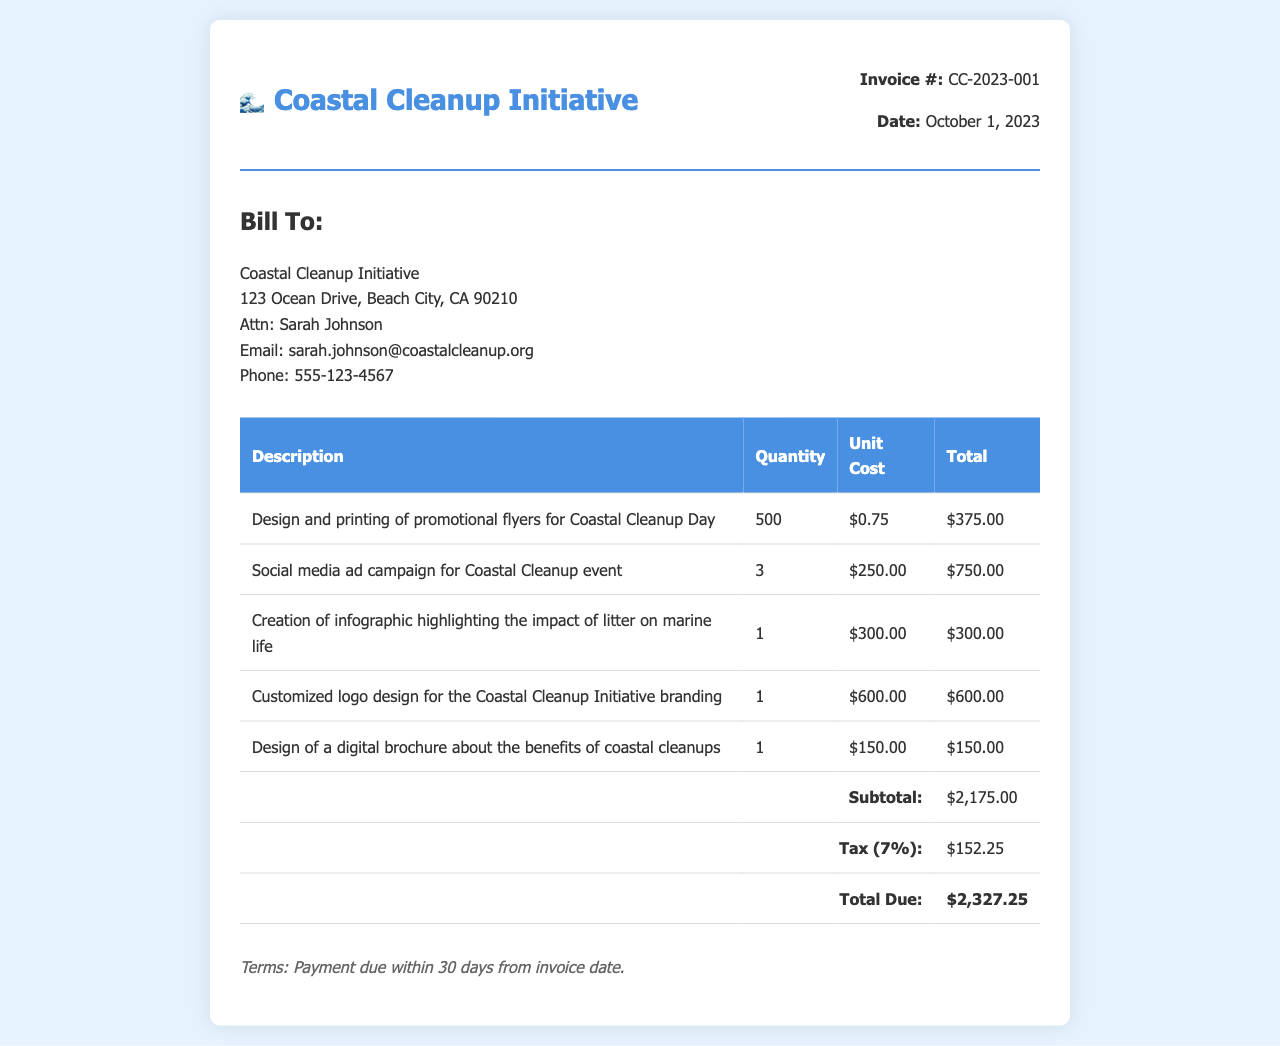What is the invoice number? The invoice number is indicated at the top of the document, labeled as "Invoice #".
Answer: CC-2023-001 What is the date of the invoice? The date is listed next to the invoice number, showing when the invoice was issued.
Answer: October 1, 2023 Who is the bill recipient? The recipient's name is shown under the "Bill To" section of the invoice.
Answer: Coastal Cleanup Initiative What is the total due amount? The total due is located at the bottom of the table, labeled as "Total Due".
Answer: $2,327.25 What is the unit cost for the social media ad campaign? The unit cost for the social media ad campaign is shown in the corresponding table row.
Answer: $250.00 How many promotional flyers were designed and printed? The quantity of flyers is detailed in the first table row under "Quantity".
Answer: 500 What is the subtotal amount? The subtotal is specified before the tax in the invoice table.
Answer: $2,175.00 What is the tax rate applied in this invoice? The tax rate is mentioned in the invoice under the tax section.
Answer: 7% What are the payment terms stated in the invoice? The payment terms are provided at the bottom of the invoice document.
Answer: Payment due within 30 days from invoice date 